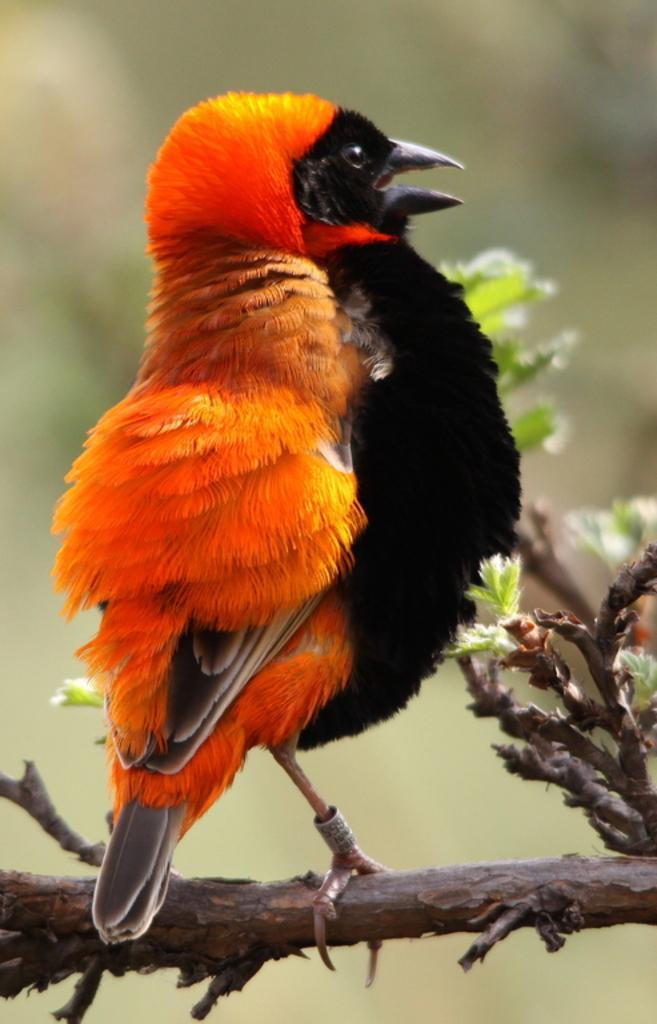Describe this image in one or two sentences. There is a bird on a stem in the foreground area of the image. 